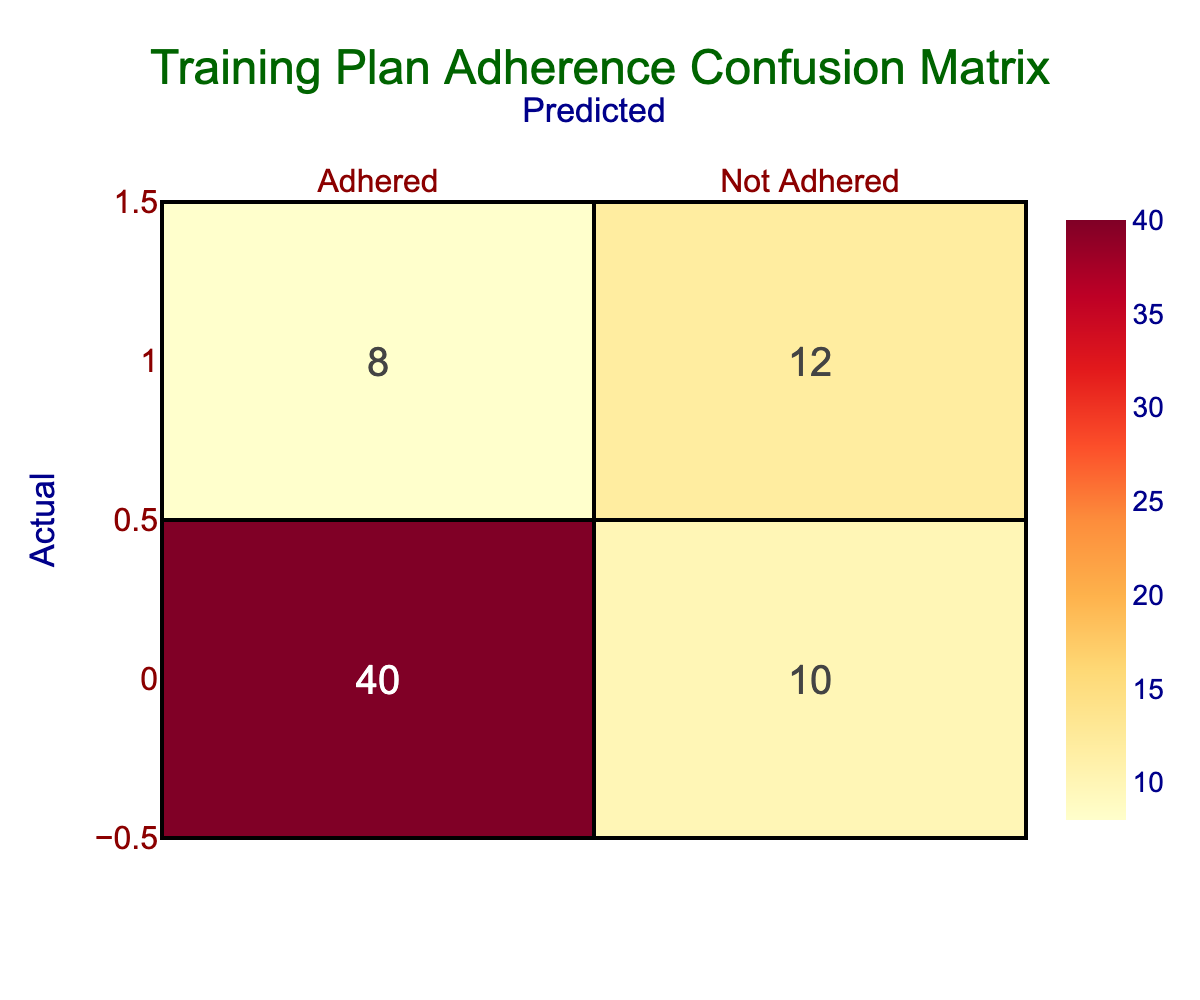What is the total number of runners who adhered to the training plan? To find the total number of runners who adhered to the training plan, we look at the "Adhered" column. The value in the "Adhered" category for "Adhered" is 40. Thus, the total number is 40.
Answer: 40 How many runners were predicted to have not adhered to the training plan but actually adhered? The table provides information in the cell where the predicted "Not Adhered" intersects with the actual "Adhered," which is 10. This means 10 runners were predicted to not adhere but actually did.
Answer: 10 What is the proportion of runners who actually adhered to the training plan? To calculate the proportion of runners who adhered to the training plan, we sum the total values in the actual "Adhered" row (40 + 10 + 8 + 12 = 70). Adhered count is 40. Therefore, the proportion is 40/70 = 0.571 or 57.1%.
Answer: 57.1% Is it true that more runners adhered to the training plan than did not? By comparing the values, we see that 40 adhered and 20 did not (10 + 12). Since 40 is greater than 20, it is true that more runners adhered to the training plan than did not.
Answer: Yes What is the total number of predictions made for runners who did not adhere to the training plan? To find the total predictions made regarding runners who did not adhere, we look at the "Not Adhered" row. The values are 8 (predicted Not Adhered for actual Adhered) and 12 (predicted Not Adhered for actual Not Adhered), summing these gives us 8 + 12 = 20.
Answer: 20 How many more runners are there in the "Adhered" category than in the "Not Adhered" category? From the table, in the "Adhered" category, there are 40 runners and in the "Not Adhered" category, 12 runners. The difference is 40 - 12 = 28. Therefore, there are 28 more runners in the "Adhered" category.
Answer: 28 What is the total count of runners across all categories? Adding all the values in the table gives the total count of runners. They are: 40 + 10 + 8 + 12 = 70. Thus, the total count of runners is 70.
Answer: 70 What percentage of runners who actually did not adhere were correctly predicted? Looking at the "Not Adhered" row under actual values, there are 12 runners who actually did not adhere, and they were correctly predicted (as "Not Adhered"). The total predicting count for non-adherence is 20 (8 + 12), so the percentage is (12/20) * 100% = 60%.
Answer: 60% 